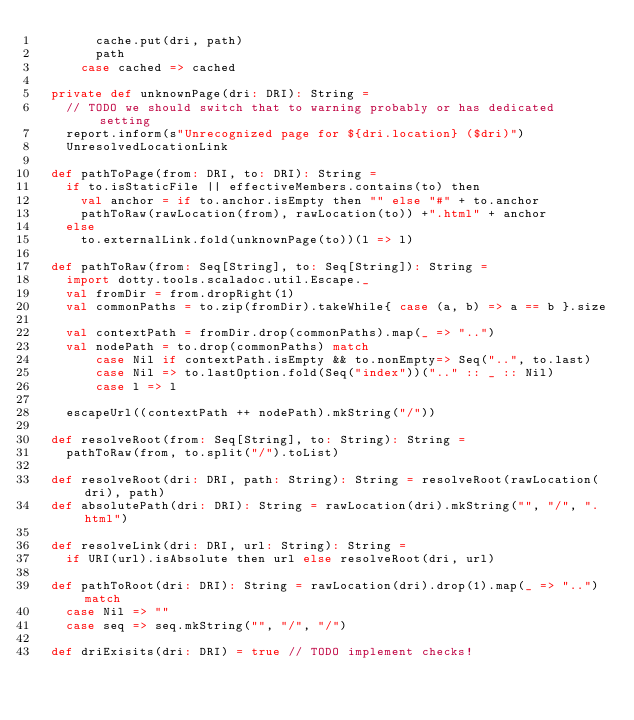Convert code to text. <code><loc_0><loc_0><loc_500><loc_500><_Scala_>        cache.put(dri, path)
        path
      case cached => cached

  private def unknownPage(dri: DRI): String =
    // TODO we should switch that to warning probably or has dedicated setting
    report.inform(s"Unrecognized page for ${dri.location} ($dri)")
    UnresolvedLocationLink

  def pathToPage(from: DRI, to: DRI): String =
    if to.isStaticFile || effectiveMembers.contains(to) then
      val anchor = if to.anchor.isEmpty then "" else "#" + to.anchor
      pathToRaw(rawLocation(from), rawLocation(to)) +".html" + anchor
    else
      to.externalLink.fold(unknownPage(to))(l => l)

  def pathToRaw(from: Seq[String], to: Seq[String]): String =
    import dotty.tools.scaladoc.util.Escape._
    val fromDir = from.dropRight(1)
    val commonPaths = to.zip(fromDir).takeWhile{ case (a, b) => a == b }.size

    val contextPath = fromDir.drop(commonPaths).map(_ => "..")
    val nodePath = to.drop(commonPaths) match
        case Nil if contextPath.isEmpty && to.nonEmpty=> Seq("..", to.last)
        case Nil => to.lastOption.fold(Seq("index"))(".." :: _ :: Nil)
        case l => l

    escapeUrl((contextPath ++ nodePath).mkString("/"))

  def resolveRoot(from: Seq[String], to: String): String =
    pathToRaw(from, to.split("/").toList)

  def resolveRoot(dri: DRI, path: String): String = resolveRoot(rawLocation(dri), path)
  def absolutePath(dri: DRI): String = rawLocation(dri).mkString("", "/", ".html")

  def resolveLink(dri: DRI, url: String): String =
    if URI(url).isAbsolute then url else resolveRoot(dri, url)

  def pathToRoot(dri: DRI): String = rawLocation(dri).drop(1).map(_ => "..") match
    case Nil => ""
    case seq => seq.mkString("", "/", "/")

  def driExisits(dri: DRI) = true // TODO implement checks!
</code> 